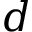<formula> <loc_0><loc_0><loc_500><loc_500>d</formula> 